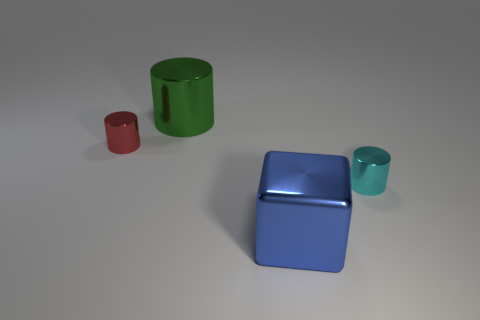Subtract all big metal cylinders. How many cylinders are left? 2 Add 2 small blue cylinders. How many objects exist? 6 Subtract 3 cylinders. How many cylinders are left? 0 Add 1 tiny rubber cylinders. How many tiny rubber cylinders exist? 1 Subtract all red cylinders. How many cylinders are left? 2 Subtract 0 gray cubes. How many objects are left? 4 Subtract all cylinders. How many objects are left? 1 Subtract all green blocks. Subtract all red cylinders. How many blocks are left? 1 Subtract all yellow cylinders. How many yellow blocks are left? 0 Subtract all small red shiny cylinders. Subtract all small cyan blocks. How many objects are left? 3 